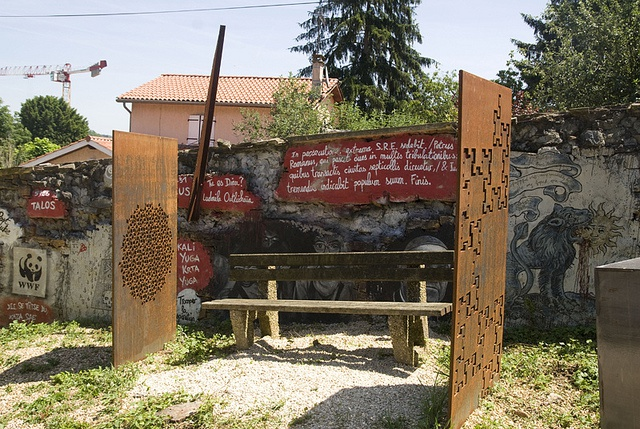Describe the objects in this image and their specific colors. I can see a bench in lavender, black, and gray tones in this image. 